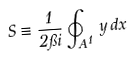<formula> <loc_0><loc_0><loc_500><loc_500>S \equiv \frac { 1 } { 2 \pi i } \oint _ { A ^ { 1 } } \, y \, d x</formula> 